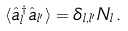<formula> <loc_0><loc_0><loc_500><loc_500>\langle \hat { a } ^ { \dagger } _ { l } \hat { a } _ { l ^ { \prime } } \rangle = \delta _ { l , l ^ { \prime } } N _ { l } \, .</formula> 